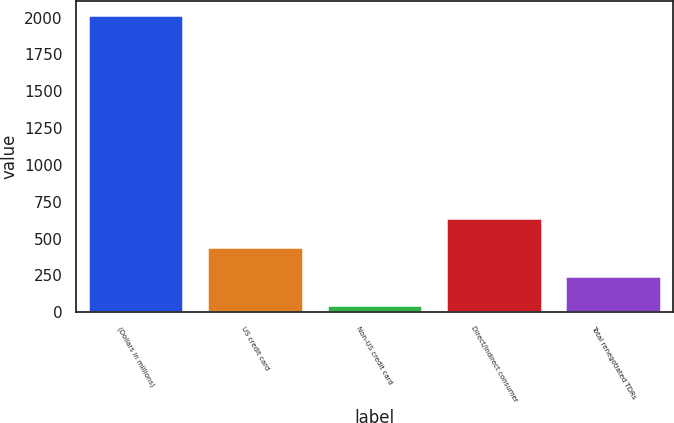<chart> <loc_0><loc_0><loc_500><loc_500><bar_chart><fcel>(Dollars in millions)<fcel>US credit card<fcel>Non-US credit card<fcel>Direct/Indirect consumer<fcel>Total renegotiated TDRs<nl><fcel>2014<fcel>440.84<fcel>47.56<fcel>637.48<fcel>244.2<nl></chart> 